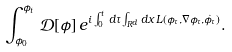<formula> <loc_0><loc_0><loc_500><loc_500>\int _ { \phi _ { 0 } } ^ { \phi _ { t } } \, \mathcal { D } [ \phi ] \, e ^ { i \int _ { 0 } ^ { t } \, d \tau \int _ { R ^ { d } } d x \, L ( \phi _ { \tau } , \nabla \phi _ { \tau } , \dot { \phi _ { \tau } } ) } .</formula> 